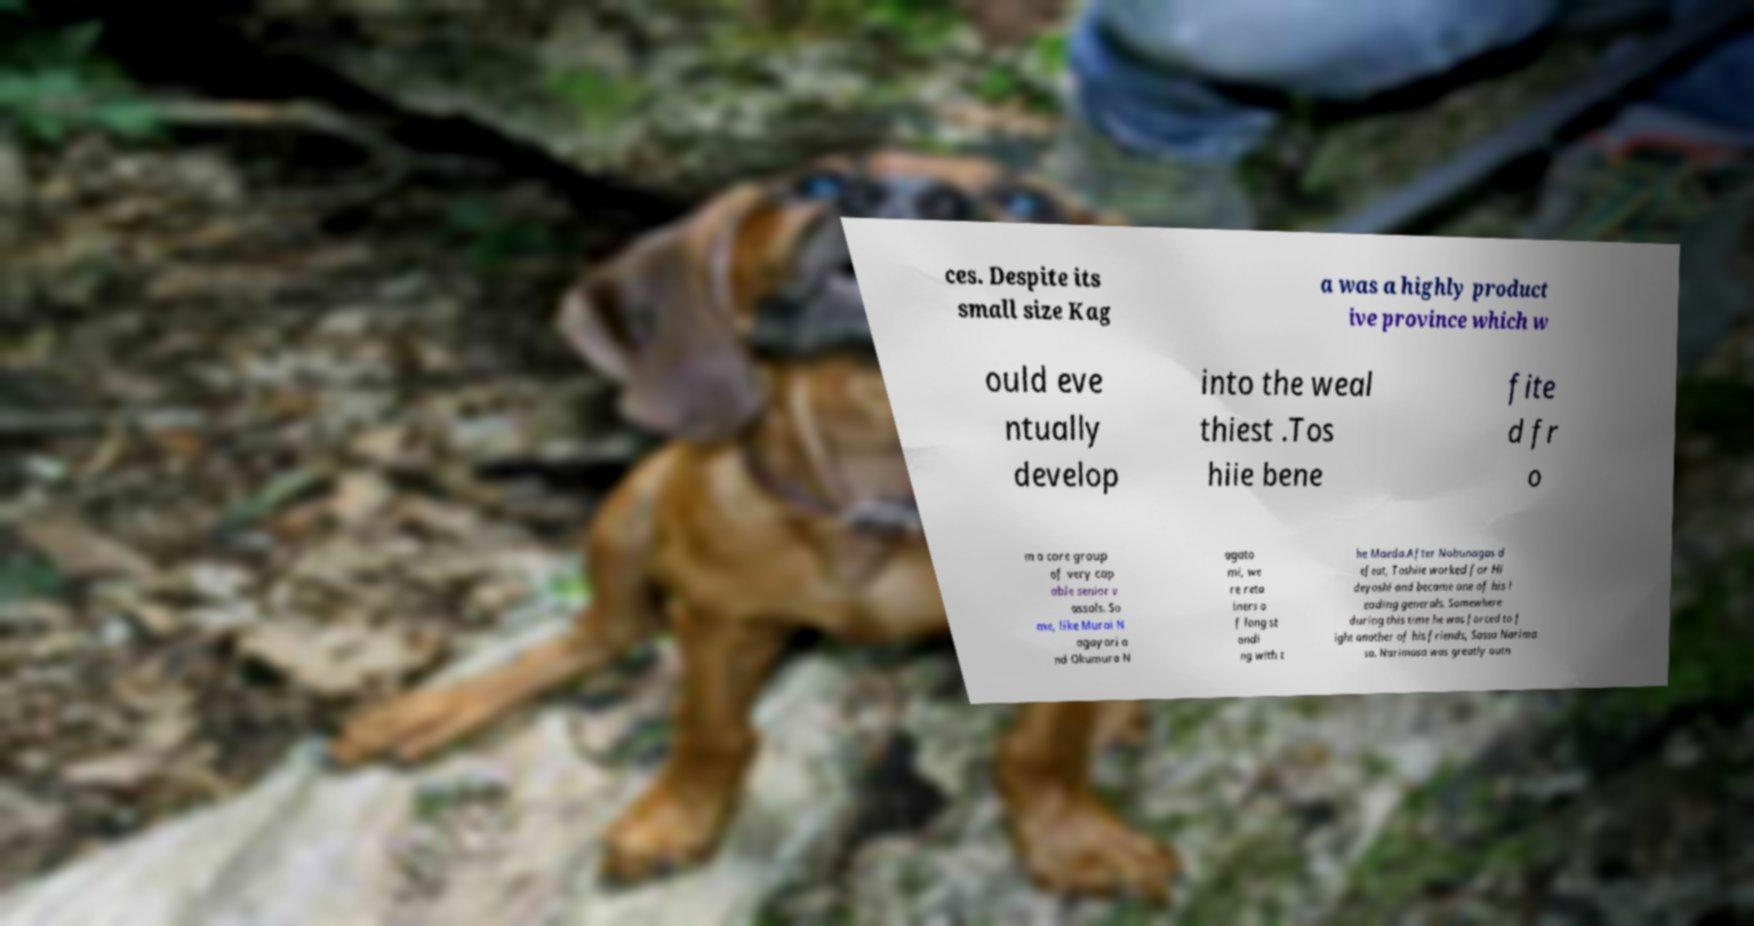Could you assist in decoding the text presented in this image and type it out clearly? ces. Despite its small size Kag a was a highly product ive province which w ould eve ntually develop into the weal thiest .Tos hiie bene fite d fr o m a core group of very cap able senior v assals. So me, like Murai N agayori a nd Okumura N agato mi, we re reta iners o f long st andi ng with t he Maeda.After Nobunagas d efeat, Toshiie worked for Hi deyoshi and became one of his l eading generals. Somewhere during this time he was forced to f ight another of his friends, Sassa Narima sa. Narimasa was greatly outn 